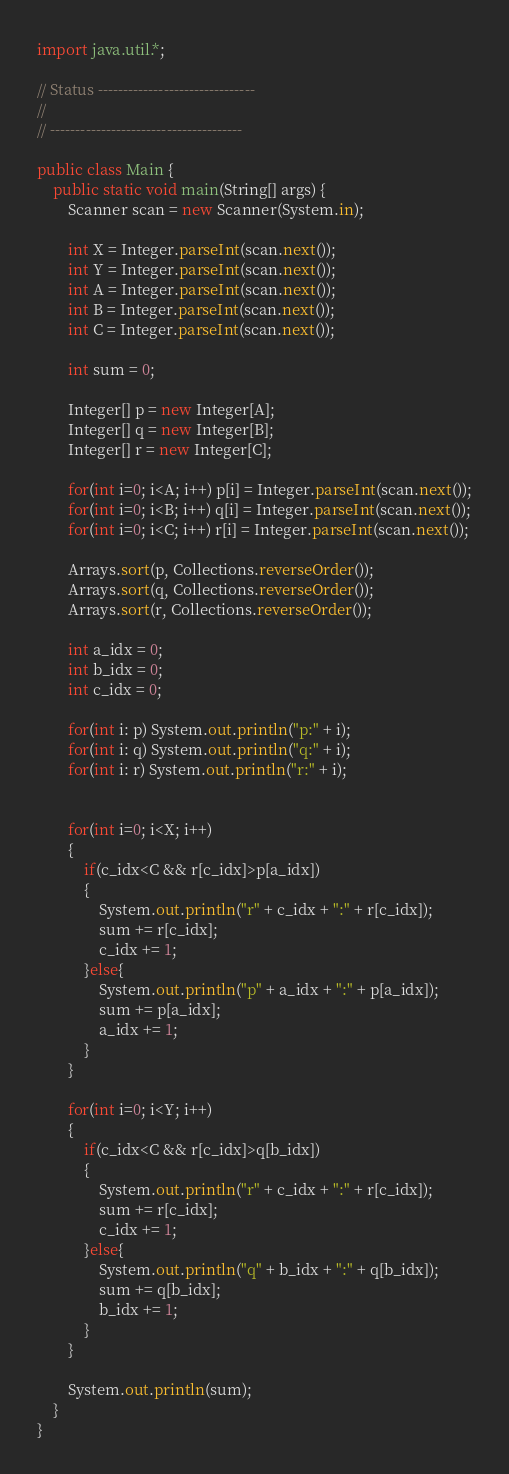<code> <loc_0><loc_0><loc_500><loc_500><_Java_>import java.util.*;

// Status -------------------------------
// 
// --------------------------------------

public class Main {
    public static void main(String[] args) {
        Scanner scan = new Scanner(System.in);

        int X = Integer.parseInt(scan.next());
        int Y = Integer.parseInt(scan.next());
        int A = Integer.parseInt(scan.next());
        int B = Integer.parseInt(scan.next());
        int C = Integer.parseInt(scan.next());

        int sum = 0;

        Integer[] p = new Integer[A];
        Integer[] q = new Integer[B];
        Integer[] r = new Integer[C];
        
        for(int i=0; i<A; i++) p[i] = Integer.parseInt(scan.next());
        for(int i=0; i<B; i++) q[i] = Integer.parseInt(scan.next());
        for(int i=0; i<C; i++) r[i] = Integer.parseInt(scan.next());

        Arrays.sort(p, Collections.reverseOrder());
        Arrays.sort(q, Collections.reverseOrder());
        Arrays.sort(r, Collections.reverseOrder());

        int a_idx = 0;
        int b_idx = 0;
        int c_idx = 0;

        for(int i: p) System.out.println("p:" + i);
        for(int i: q) System.out.println("q:" + i);
        for(int i: r) System.out.println("r:" + i);


        for(int i=0; i<X; i++)
        {
            if(c_idx<C && r[c_idx]>p[a_idx])
            {
                System.out.println("r" + c_idx + ":" + r[c_idx]);
                sum += r[c_idx];
                c_idx += 1;
            }else{
                System.out.println("p" + a_idx + ":" + p[a_idx]);
                sum += p[a_idx];
                a_idx += 1;
            }
        }

        for(int i=0; i<Y; i++)
        {
            if(c_idx<C && r[c_idx]>q[b_idx])
            {
                System.out.println("r" + c_idx + ":" + r[c_idx]);
                sum += r[c_idx];
                c_idx += 1;
            }else{
                System.out.println("q" + b_idx + ":" + q[b_idx]);
                sum += q[b_idx];
                b_idx += 1;
            }
        }

        System.out.println(sum);
    }
}</code> 